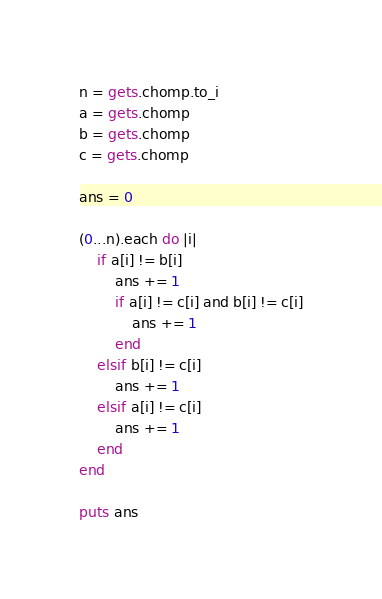Convert code to text. <code><loc_0><loc_0><loc_500><loc_500><_Ruby_>n = gets.chomp.to_i
a = gets.chomp
b = gets.chomp
c = gets.chomp

ans = 0

(0...n).each do |i|
    if a[i] != b[i]
        ans += 1
        if a[i] != c[i] and b[i] != c[i]
            ans += 1
        end
    elsif b[i] != c[i]
        ans += 1
    elsif a[i] != c[i]
        ans += 1
    end
end

puts ans</code> 